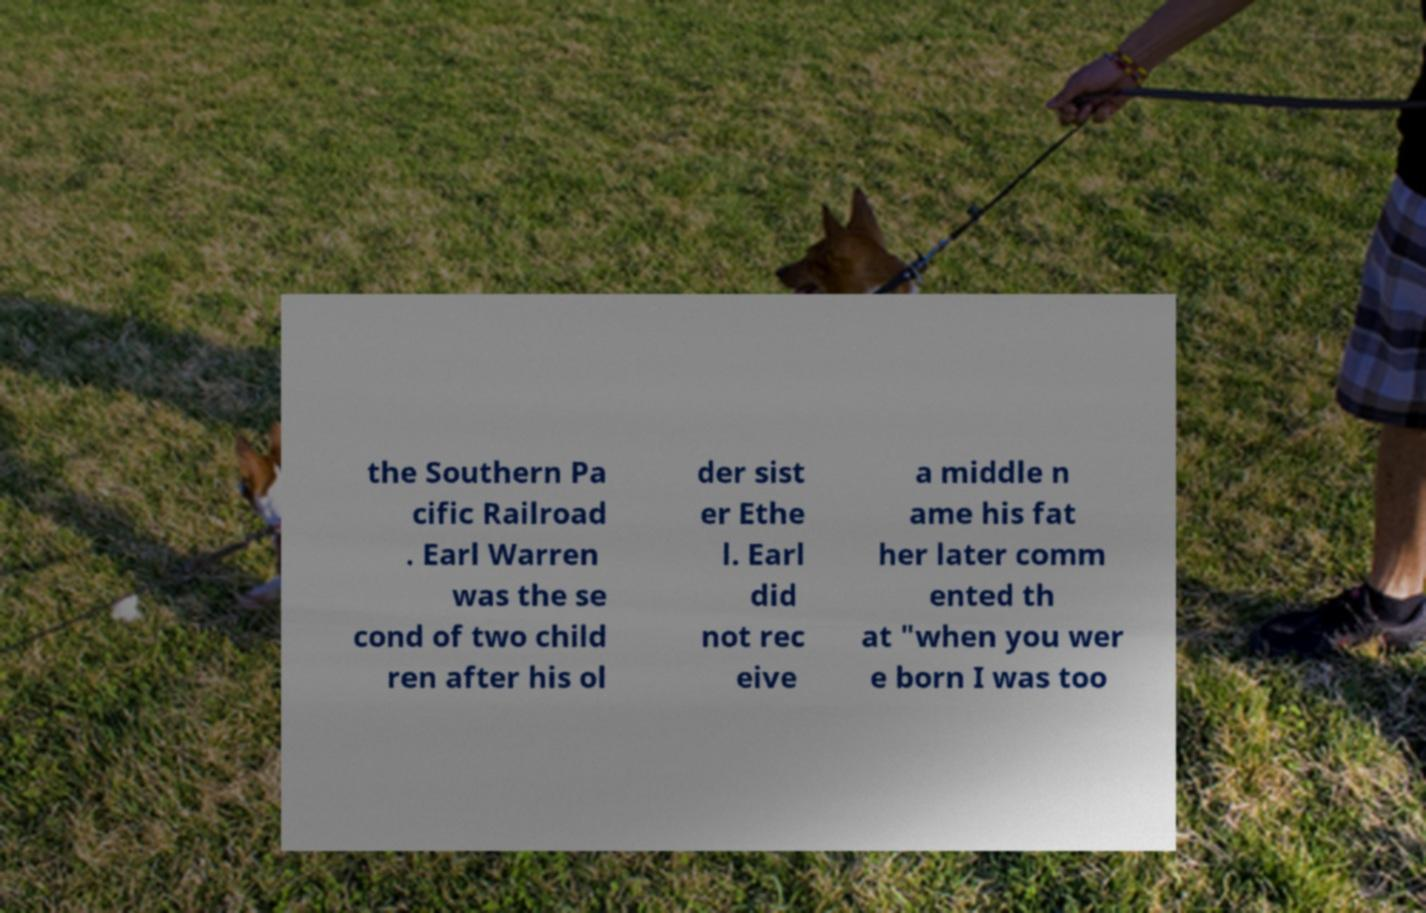Could you assist in decoding the text presented in this image and type it out clearly? the Southern Pa cific Railroad . Earl Warren was the se cond of two child ren after his ol der sist er Ethe l. Earl did not rec eive a middle n ame his fat her later comm ented th at "when you wer e born I was too 